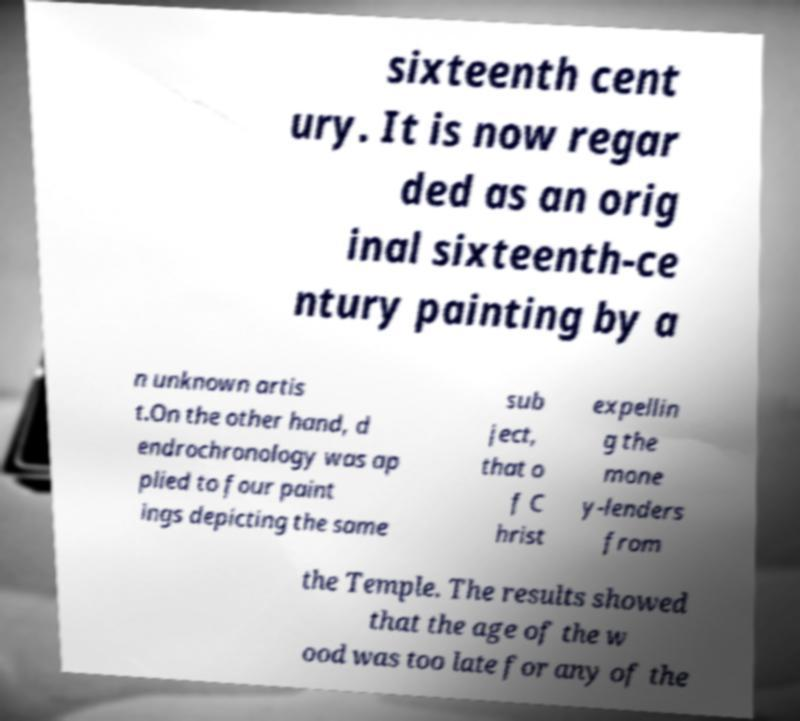Can you read and provide the text displayed in the image?This photo seems to have some interesting text. Can you extract and type it out for me? sixteenth cent ury. It is now regar ded as an orig inal sixteenth-ce ntury painting by a n unknown artis t.On the other hand, d endrochronology was ap plied to four paint ings depicting the same sub ject, that o f C hrist expellin g the mone y-lenders from the Temple. The results showed that the age of the w ood was too late for any of the 